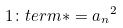<formula> <loc_0><loc_0><loc_500><loc_500>1 \colon t e r m * = { a _ { n } } ^ { 2 }</formula> 